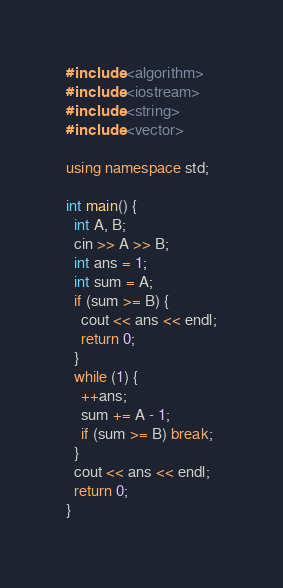Convert code to text. <code><loc_0><loc_0><loc_500><loc_500><_C++_>#include <algorithm>
#include <iostream>
#include <string>
#include <vector>

using namespace std;

int main() {
  int A, B;
  cin >> A >> B;
  int ans = 1;
  int sum = A;
  if (sum >= B) {
    cout << ans << endl;
    return 0;
  }
  while (1) {
    ++ans;
    sum += A - 1;
    if (sum >= B) break;
  }
  cout << ans << endl;
  return 0;
}
</code> 